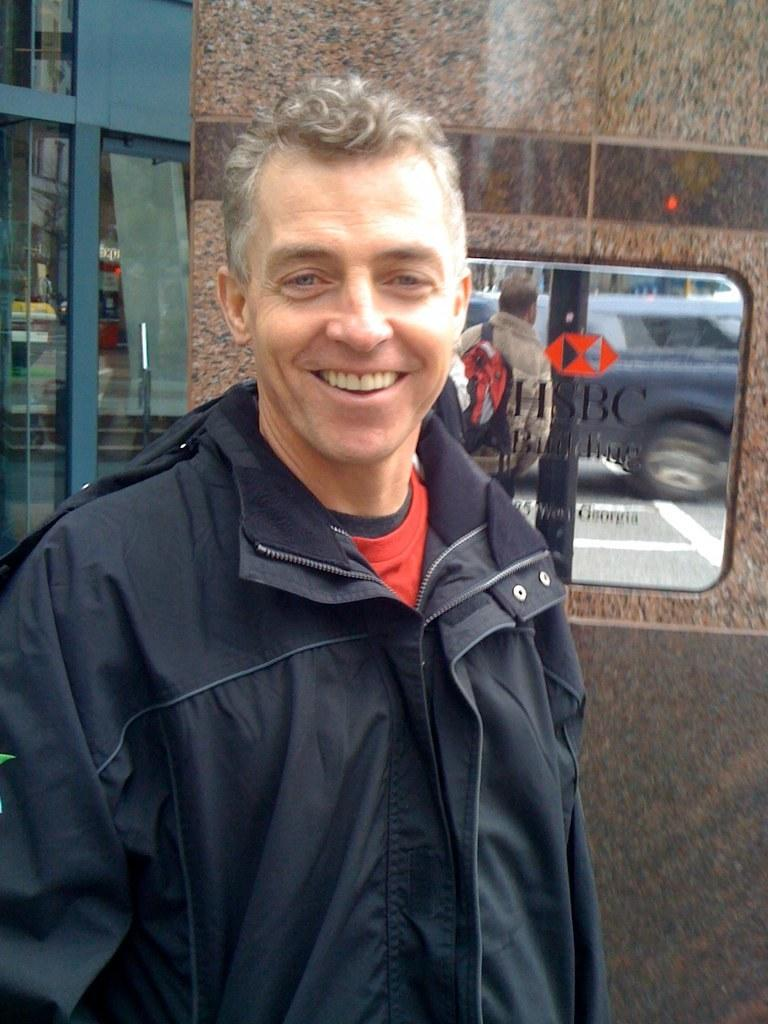Who is present in the image? There is a man in the image. What is the man's facial expression? The man is smiling. What can be seen in the background of the image? There is a wall, a board, and glasses in the background of the image. What is depicted on the board? The board reflects a person and a car. What type of slave is depicted on the board in the image? There is no slave depicted on the board in the image; it reflects a person and a car. What stage of development is the fairy in the image? There are no fairies present in the image. 